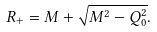<formula> <loc_0><loc_0><loc_500><loc_500>R _ { + } = M + \sqrt { M ^ { 2 } - Q _ { 0 } ^ { 2 } } .</formula> 